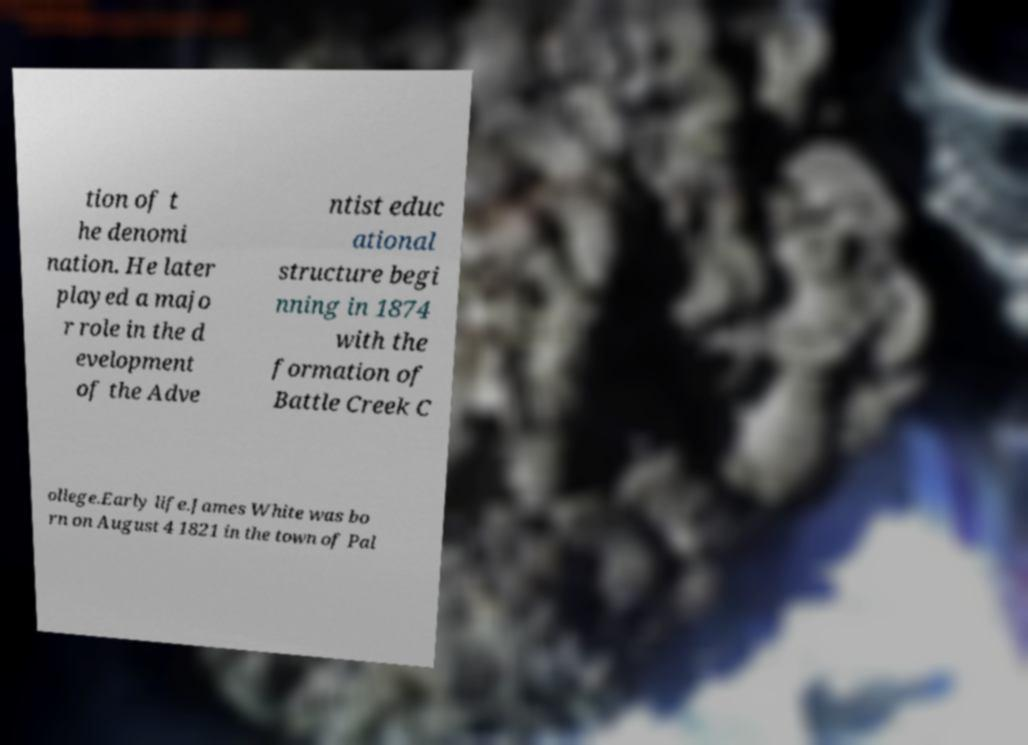Can you accurately transcribe the text from the provided image for me? tion of t he denomi nation. He later played a majo r role in the d evelopment of the Adve ntist educ ational structure begi nning in 1874 with the formation of Battle Creek C ollege.Early life.James White was bo rn on August 4 1821 in the town of Pal 